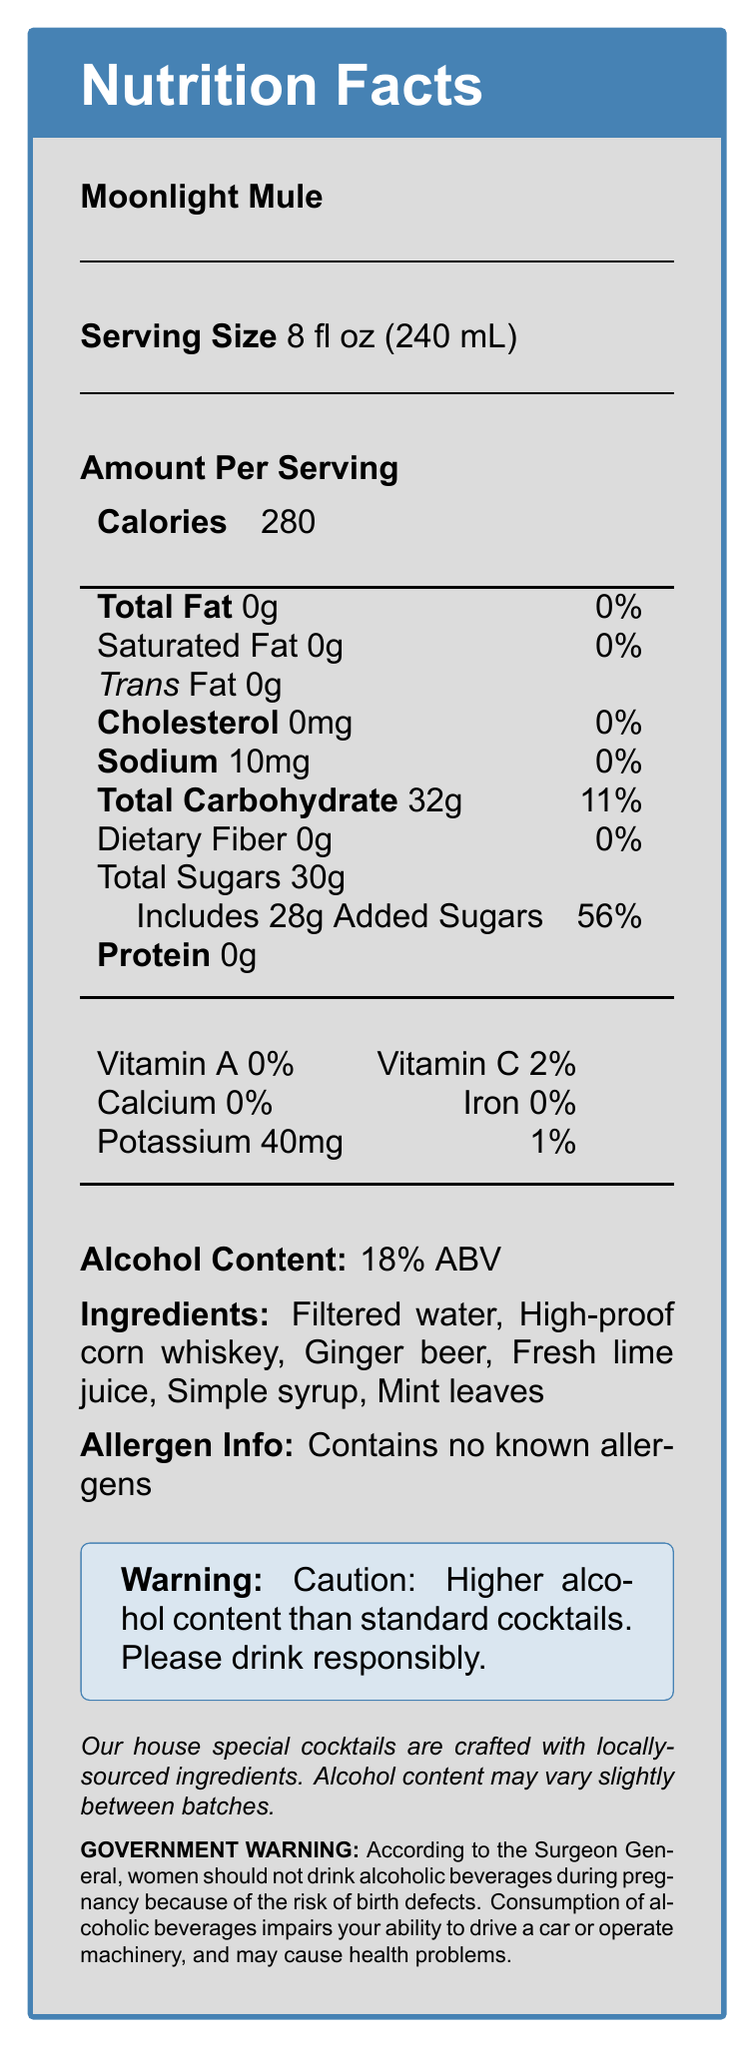What is the serving size of Moonlight Mule? The document states that the serving size of Moonlight Mule is 8 fl oz (240 mL).
Answer: 8 fl oz (240 mL) How many calories are in one serving of Moonlight Mule? The document shows that there are 280 calories per serving.
Answer: 280 What is the alcohol content in the Moonlight Mule? The document states that the alcohol content of the Moonlight Mule is 18% ABV.
Answer: 18% ABV How much sodium does a serving of Moonlight Mule contain? The document mentions that one serving contains 10mg of sodium.
Answer: 10mg What is the amount of added sugars in one serving of Moonlight Mule? The document specifies that there are 28g of added sugars in one serving.
Answer: 28g Which ingredient is used as the main alcoholic component in the Moonlight Mule? The ingredients list indicates that high-proof corn whiskey is used in the cocktail.
Answer: High-proof corn whiskey What does the allergen info say about Moonlight Mule? A. Contains nuts B. Contains dairy C. Contains no known allergens D. Gluten-free The document states "Contains no known allergens."
Answer: C What vitamins and minerals are absent in the Moonlight Mule? A. Vitamin A, Calcium, Iron B. Vitamin C, Iron, Sodium C. Calcium, Potassium, Vitamin A D. Iron, Vitamin A, Potassium The document lists 0% for Vitamin A, Calcium, and Iron.
Answer: A What is the amount of total carbohydrates in a serving of Moonlight Mule? The document indicates there are 32g of total carbohydrates per serving.
Answer: 32g Does the Moonlight Mule contain any dietary fiber? The document shows that dietary fiber content is 0g.
Answer: No Summarize the main nutritional content and warnings provided for Moonlight Mule. The document describes the nutritional information: calories, fat, sodium, carbohydrates, sugars, and alcohol content. It also lists ingredients and mentions no known allergens, along with warnings about its high alcohol content and associated health risks.
Answer: The Moonlight Mule is an 8 fl oz cocktail with 280 calories, 0g fat, 10mg sodium, 32g carbohydrates including 28g added sugars, and 18% ABV. It includes ingredients like high-proof corn whiskey and ginger beer, and contains no known allergens. There is a warning due to its higher alcohol content. Is it safe for pregnant women to consume the Moonlight Mule according to the government warning? The government warning advises that women should not drink alcoholic beverages during pregnancy due to the risk of birth defects.
Answer: No Is the alcohol content of the Moonlight Mule higher than standard cocktails? The document explicitly states "Caution: Higher alcohol content than standard cocktails."
Answer: Yes Can the exact alcohol content of Moonlight Mule be reliably determined from batch to batch? The document mentions that the alcohol content may vary slightly between batches, indicating potential variability.
Answer: No How much potassium is in a serving of Moonlight Mule? The document indicates there are 40mg of potassium in one serving.
Answer: 40mg What is the total fat percentage in the Moonlight Mule? The document states that the total fat is 0g, translating to 0% of the daily value.
Answer: 0% Which ingredient is used for sweetening the Moonlight Mule? The ingredients list includes simple syrup, which is used for sweetening.
Answer: Simple syrup 